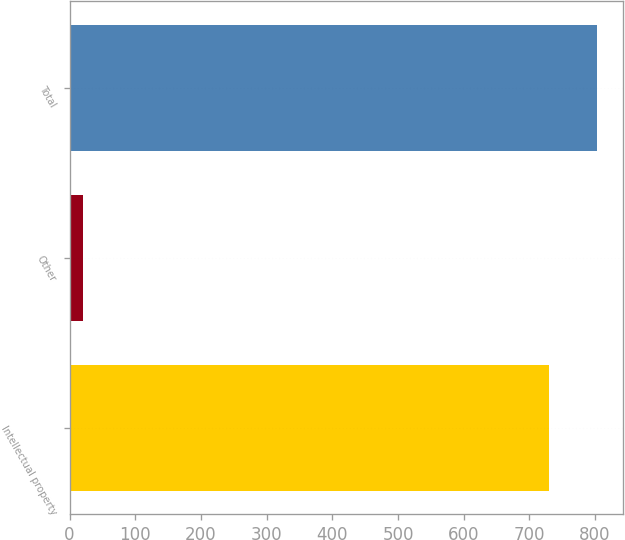Convert chart. <chart><loc_0><loc_0><loc_500><loc_500><bar_chart><fcel>Intellectual property<fcel>Other<fcel>Total<nl><fcel>730<fcel>21<fcel>803<nl></chart> 